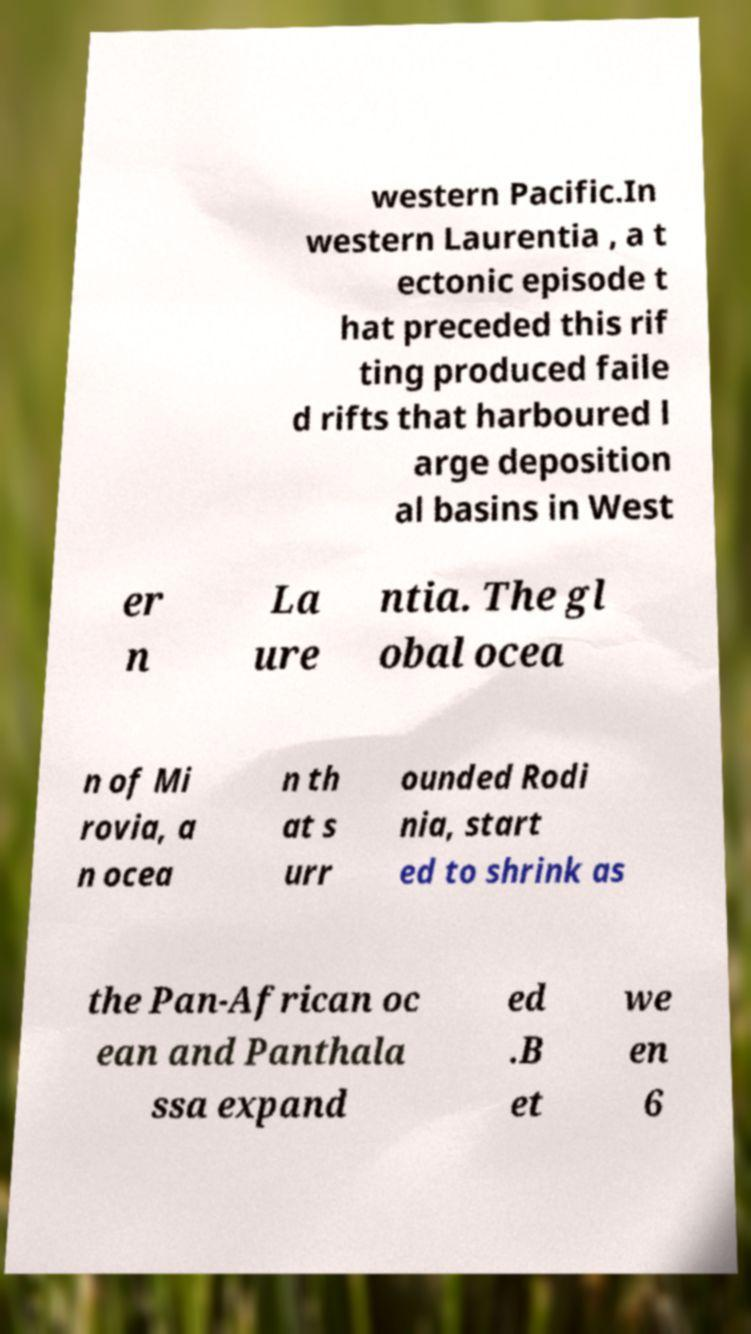Can you accurately transcribe the text from the provided image for me? western Pacific.In western Laurentia , a t ectonic episode t hat preceded this rif ting produced faile d rifts that harboured l arge deposition al basins in West er n La ure ntia. The gl obal ocea n of Mi rovia, a n ocea n th at s urr ounded Rodi nia, start ed to shrink as the Pan-African oc ean and Panthala ssa expand ed .B et we en 6 